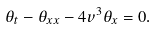<formula> <loc_0><loc_0><loc_500><loc_500>\theta _ { t } - \theta _ { x x } - 4 v ^ { 3 } \theta _ { x } = 0 .</formula> 